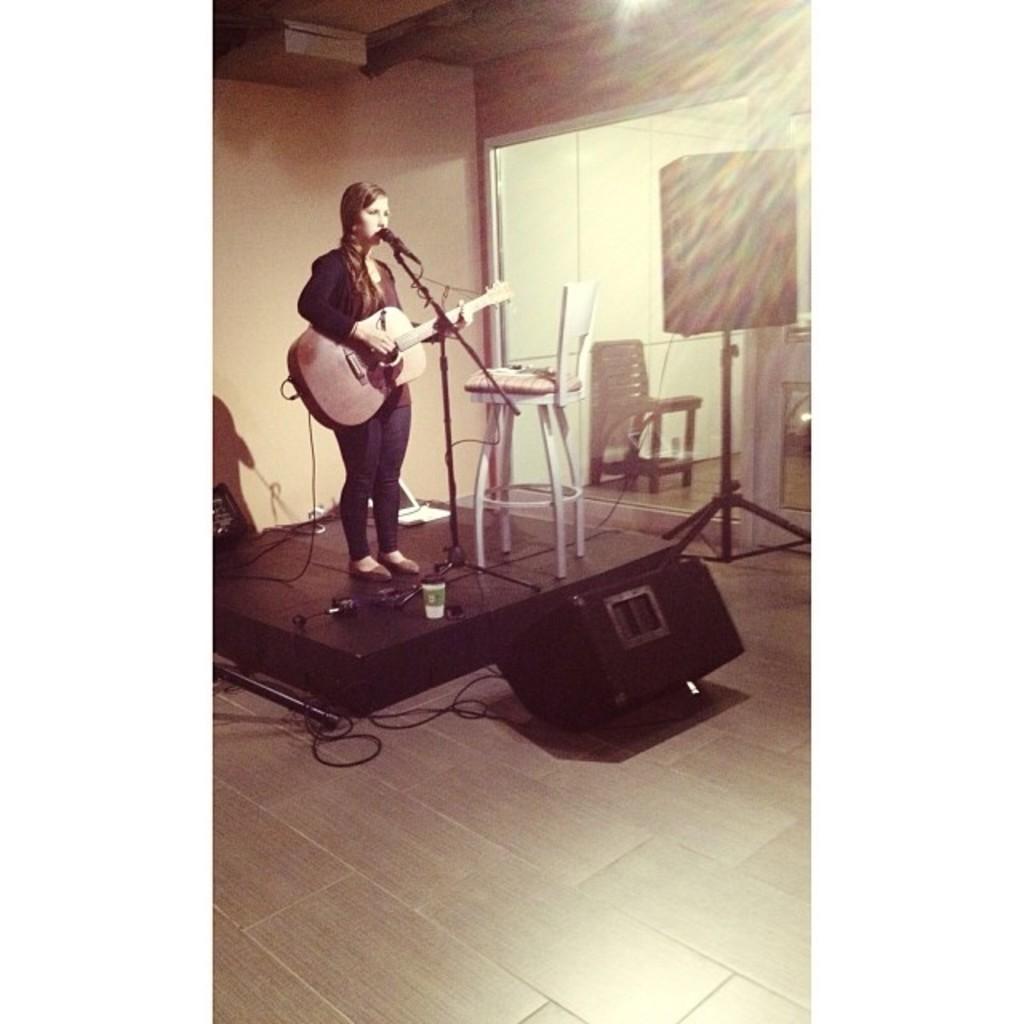Could you give a brief overview of what you see in this image? In this picture a woman is standing on a stage in the left corner. She is holding a guitar and singing on a mike. Besides her there is a chair and behind her there is a wall, in front of her there is a sound speaker. In the right side there is a sound speaker and chair. 